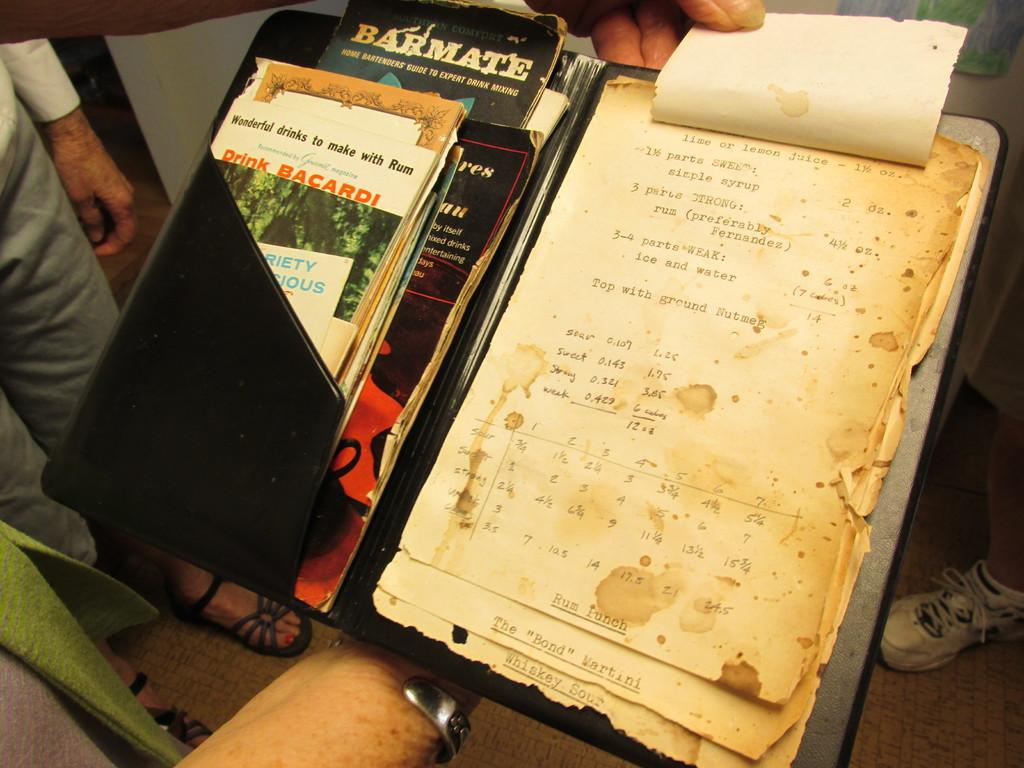Provide a one-sentence caption for the provided image. An old recipe book for cocktails with "lime or lemon juice" as an ingredient. 